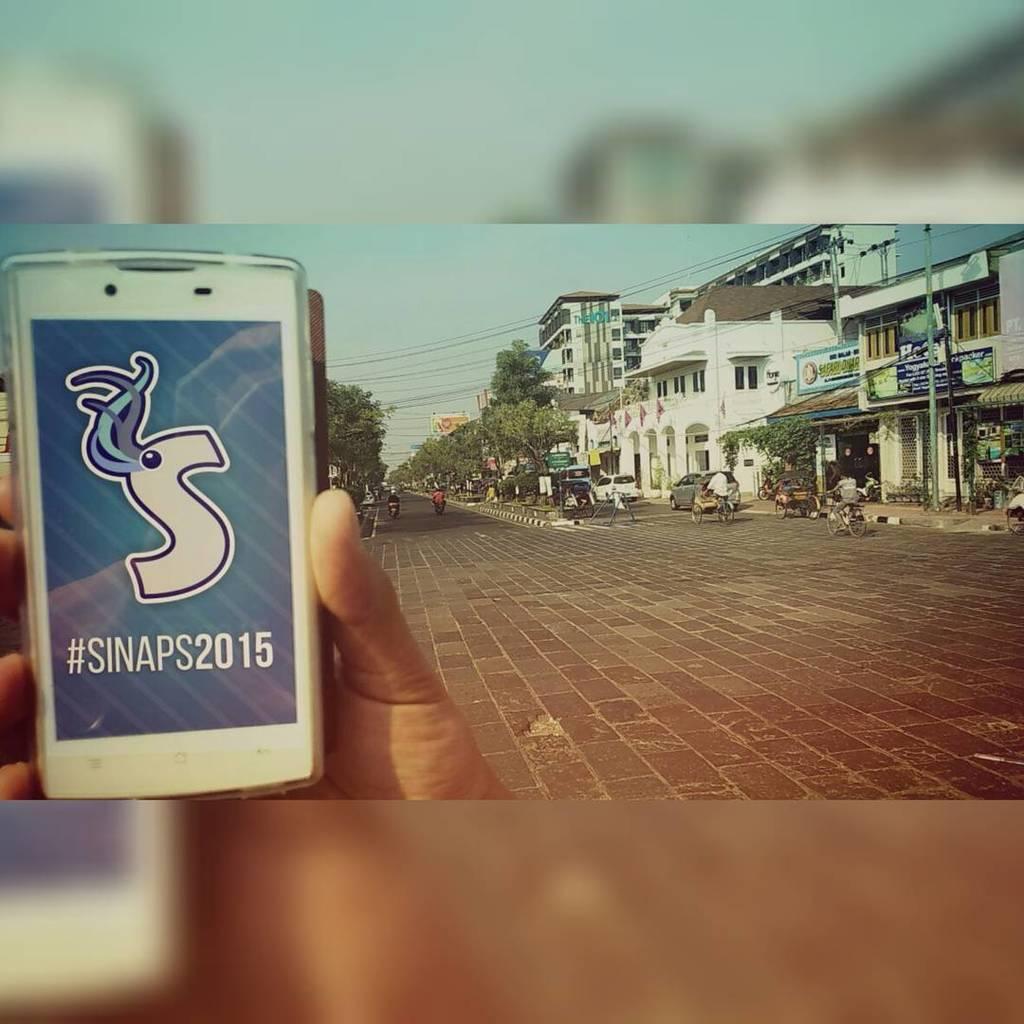What does the hashtag say?
Offer a very short reply. Sinaps2015. It says #sinaps2015?
Your answer should be very brief. Yes. 